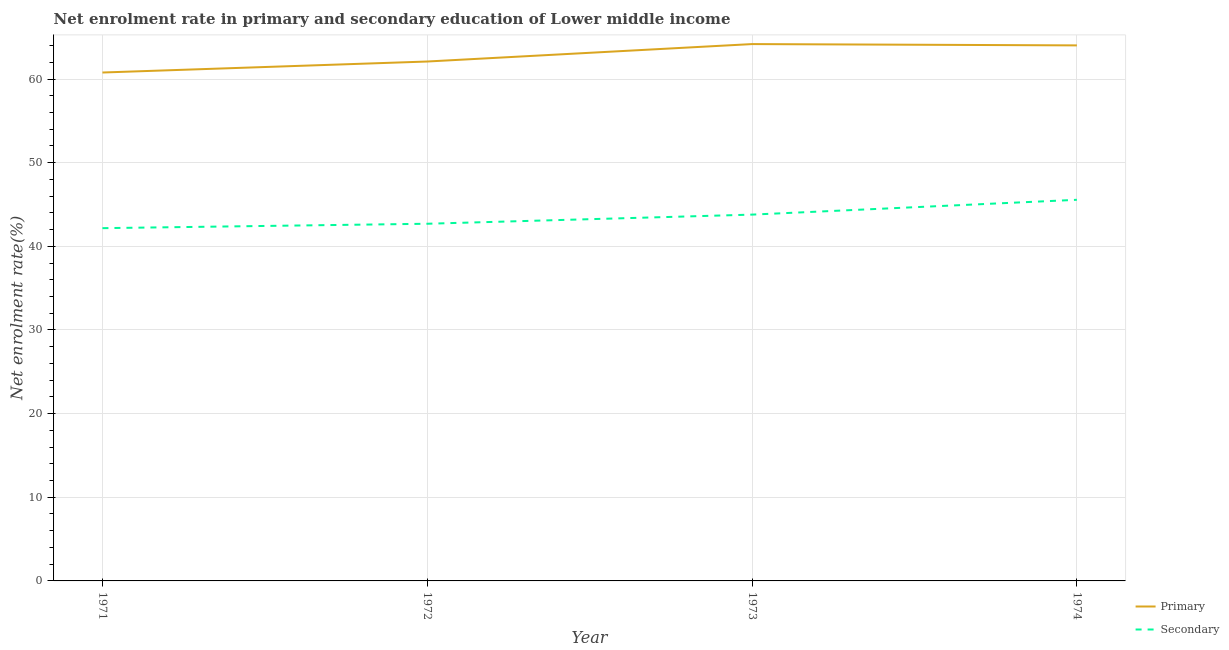How many different coloured lines are there?
Keep it short and to the point. 2. What is the enrollment rate in secondary education in 1972?
Give a very brief answer. 42.7. Across all years, what is the maximum enrollment rate in secondary education?
Make the answer very short. 45.56. Across all years, what is the minimum enrollment rate in primary education?
Provide a succinct answer. 60.78. What is the total enrollment rate in secondary education in the graph?
Make the answer very short. 174.22. What is the difference between the enrollment rate in primary education in 1971 and that in 1974?
Your response must be concise. -3.24. What is the difference between the enrollment rate in secondary education in 1974 and the enrollment rate in primary education in 1972?
Provide a succinct answer. -16.53. What is the average enrollment rate in primary education per year?
Your response must be concise. 62.77. In the year 1974, what is the difference between the enrollment rate in secondary education and enrollment rate in primary education?
Provide a succinct answer. -18.46. What is the ratio of the enrollment rate in primary education in 1972 to that in 1974?
Keep it short and to the point. 0.97. Is the difference between the enrollment rate in secondary education in 1973 and 1974 greater than the difference between the enrollment rate in primary education in 1973 and 1974?
Ensure brevity in your answer.  No. What is the difference between the highest and the second highest enrollment rate in primary education?
Provide a short and direct response. 0.16. What is the difference between the highest and the lowest enrollment rate in primary education?
Give a very brief answer. 3.4. Is the enrollment rate in secondary education strictly less than the enrollment rate in primary education over the years?
Provide a succinct answer. Yes. How many years are there in the graph?
Your response must be concise. 4. What is the difference between two consecutive major ticks on the Y-axis?
Provide a short and direct response. 10. Are the values on the major ticks of Y-axis written in scientific E-notation?
Your response must be concise. No. Where does the legend appear in the graph?
Give a very brief answer. Bottom right. How are the legend labels stacked?
Keep it short and to the point. Vertical. What is the title of the graph?
Your answer should be very brief. Net enrolment rate in primary and secondary education of Lower middle income. Does "Electricity and heat production" appear as one of the legend labels in the graph?
Your answer should be very brief. No. What is the label or title of the Y-axis?
Keep it short and to the point. Net enrolment rate(%). What is the Net enrolment rate(%) in Primary in 1971?
Your answer should be compact. 60.78. What is the Net enrolment rate(%) in Secondary in 1971?
Your answer should be compact. 42.17. What is the Net enrolment rate(%) in Primary in 1972?
Your response must be concise. 62.09. What is the Net enrolment rate(%) in Secondary in 1972?
Your response must be concise. 42.7. What is the Net enrolment rate(%) in Primary in 1973?
Your answer should be compact. 64.18. What is the Net enrolment rate(%) of Secondary in 1973?
Offer a terse response. 43.79. What is the Net enrolment rate(%) in Primary in 1974?
Give a very brief answer. 64.02. What is the Net enrolment rate(%) in Secondary in 1974?
Keep it short and to the point. 45.56. Across all years, what is the maximum Net enrolment rate(%) in Primary?
Offer a very short reply. 64.18. Across all years, what is the maximum Net enrolment rate(%) in Secondary?
Ensure brevity in your answer.  45.56. Across all years, what is the minimum Net enrolment rate(%) in Primary?
Provide a succinct answer. 60.78. Across all years, what is the minimum Net enrolment rate(%) of Secondary?
Your answer should be compact. 42.17. What is the total Net enrolment rate(%) of Primary in the graph?
Your answer should be very brief. 251.06. What is the total Net enrolment rate(%) of Secondary in the graph?
Offer a very short reply. 174.22. What is the difference between the Net enrolment rate(%) in Primary in 1971 and that in 1972?
Offer a terse response. -1.31. What is the difference between the Net enrolment rate(%) in Secondary in 1971 and that in 1972?
Offer a very short reply. -0.53. What is the difference between the Net enrolment rate(%) of Primary in 1971 and that in 1973?
Provide a short and direct response. -3.4. What is the difference between the Net enrolment rate(%) in Secondary in 1971 and that in 1973?
Give a very brief answer. -1.62. What is the difference between the Net enrolment rate(%) of Primary in 1971 and that in 1974?
Keep it short and to the point. -3.24. What is the difference between the Net enrolment rate(%) of Secondary in 1971 and that in 1974?
Make the answer very short. -3.39. What is the difference between the Net enrolment rate(%) in Primary in 1972 and that in 1973?
Offer a very short reply. -2.08. What is the difference between the Net enrolment rate(%) of Secondary in 1972 and that in 1973?
Your answer should be compact. -1.09. What is the difference between the Net enrolment rate(%) of Primary in 1972 and that in 1974?
Provide a short and direct response. -1.93. What is the difference between the Net enrolment rate(%) in Secondary in 1972 and that in 1974?
Offer a very short reply. -2.86. What is the difference between the Net enrolment rate(%) of Primary in 1973 and that in 1974?
Provide a short and direct response. 0.16. What is the difference between the Net enrolment rate(%) in Secondary in 1973 and that in 1974?
Your answer should be very brief. -1.77. What is the difference between the Net enrolment rate(%) of Primary in 1971 and the Net enrolment rate(%) of Secondary in 1972?
Make the answer very short. 18.08. What is the difference between the Net enrolment rate(%) in Primary in 1971 and the Net enrolment rate(%) in Secondary in 1973?
Provide a short and direct response. 16.99. What is the difference between the Net enrolment rate(%) of Primary in 1971 and the Net enrolment rate(%) of Secondary in 1974?
Keep it short and to the point. 15.22. What is the difference between the Net enrolment rate(%) of Primary in 1972 and the Net enrolment rate(%) of Secondary in 1973?
Your response must be concise. 18.3. What is the difference between the Net enrolment rate(%) in Primary in 1972 and the Net enrolment rate(%) in Secondary in 1974?
Keep it short and to the point. 16.53. What is the difference between the Net enrolment rate(%) in Primary in 1973 and the Net enrolment rate(%) in Secondary in 1974?
Ensure brevity in your answer.  18.62. What is the average Net enrolment rate(%) in Primary per year?
Your answer should be compact. 62.77. What is the average Net enrolment rate(%) in Secondary per year?
Your answer should be compact. 43.55. In the year 1971, what is the difference between the Net enrolment rate(%) of Primary and Net enrolment rate(%) of Secondary?
Provide a succinct answer. 18.61. In the year 1972, what is the difference between the Net enrolment rate(%) of Primary and Net enrolment rate(%) of Secondary?
Your answer should be compact. 19.39. In the year 1973, what is the difference between the Net enrolment rate(%) in Primary and Net enrolment rate(%) in Secondary?
Offer a very short reply. 20.39. In the year 1974, what is the difference between the Net enrolment rate(%) in Primary and Net enrolment rate(%) in Secondary?
Your answer should be very brief. 18.46. What is the ratio of the Net enrolment rate(%) of Primary in 1971 to that in 1972?
Offer a very short reply. 0.98. What is the ratio of the Net enrolment rate(%) in Secondary in 1971 to that in 1972?
Your response must be concise. 0.99. What is the ratio of the Net enrolment rate(%) in Primary in 1971 to that in 1973?
Ensure brevity in your answer.  0.95. What is the ratio of the Net enrolment rate(%) of Secondary in 1971 to that in 1973?
Provide a short and direct response. 0.96. What is the ratio of the Net enrolment rate(%) of Primary in 1971 to that in 1974?
Your answer should be compact. 0.95. What is the ratio of the Net enrolment rate(%) in Secondary in 1971 to that in 1974?
Offer a terse response. 0.93. What is the ratio of the Net enrolment rate(%) in Primary in 1972 to that in 1973?
Offer a very short reply. 0.97. What is the ratio of the Net enrolment rate(%) in Secondary in 1972 to that in 1973?
Offer a terse response. 0.98. What is the ratio of the Net enrolment rate(%) in Primary in 1972 to that in 1974?
Offer a terse response. 0.97. What is the ratio of the Net enrolment rate(%) of Secondary in 1972 to that in 1974?
Provide a succinct answer. 0.94. What is the ratio of the Net enrolment rate(%) of Secondary in 1973 to that in 1974?
Your answer should be very brief. 0.96. What is the difference between the highest and the second highest Net enrolment rate(%) of Primary?
Make the answer very short. 0.16. What is the difference between the highest and the second highest Net enrolment rate(%) in Secondary?
Offer a terse response. 1.77. What is the difference between the highest and the lowest Net enrolment rate(%) of Primary?
Offer a terse response. 3.4. What is the difference between the highest and the lowest Net enrolment rate(%) in Secondary?
Your response must be concise. 3.39. 